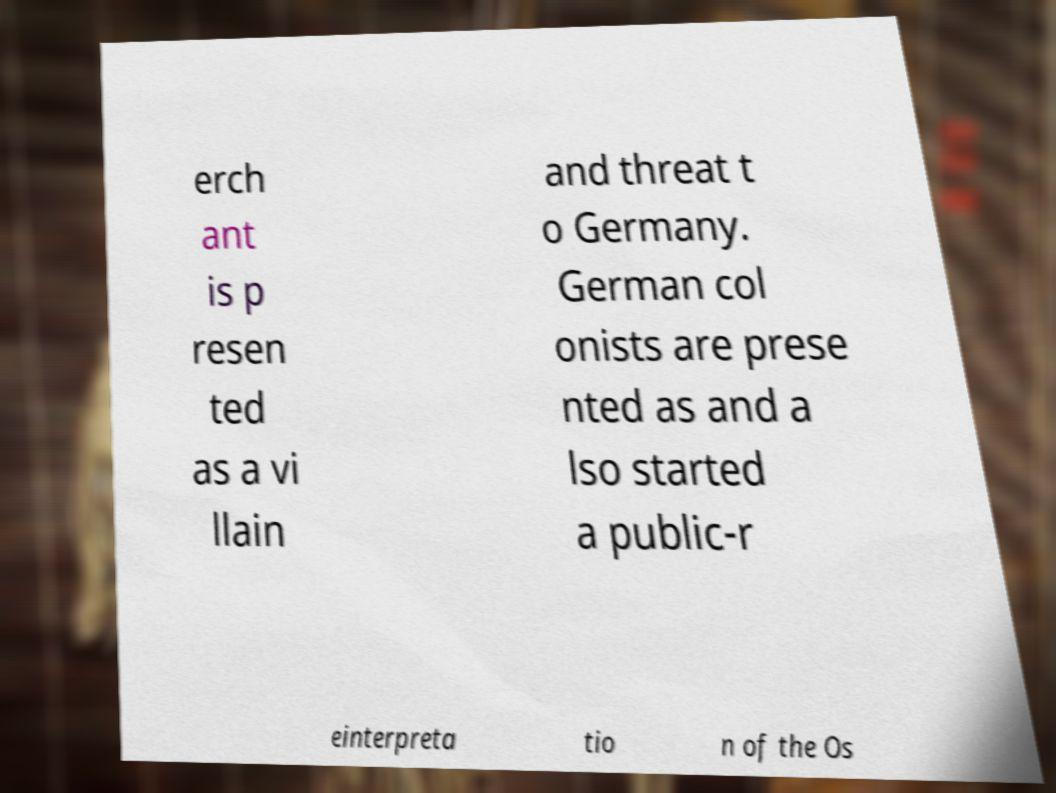For documentation purposes, I need the text within this image transcribed. Could you provide that? erch ant is p resen ted as a vi llain and threat t o Germany. German col onists are prese nted as and a lso started a public-r einterpreta tio n of the Os 